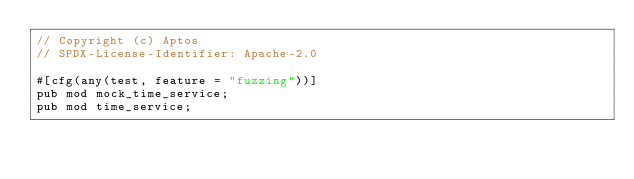Convert code to text. <code><loc_0><loc_0><loc_500><loc_500><_Rust_>// Copyright (c) Aptos
// SPDX-License-Identifier: Apache-2.0

#[cfg(any(test, feature = "fuzzing"))]
pub mod mock_time_service;
pub mod time_service;
</code> 